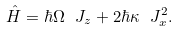<formula> <loc_0><loc_0><loc_500><loc_500>\hat { H } = \hbar { \Omega } \ J _ { z } + 2 \hbar { \kappa } \ J _ { x } ^ { 2 } .</formula> 